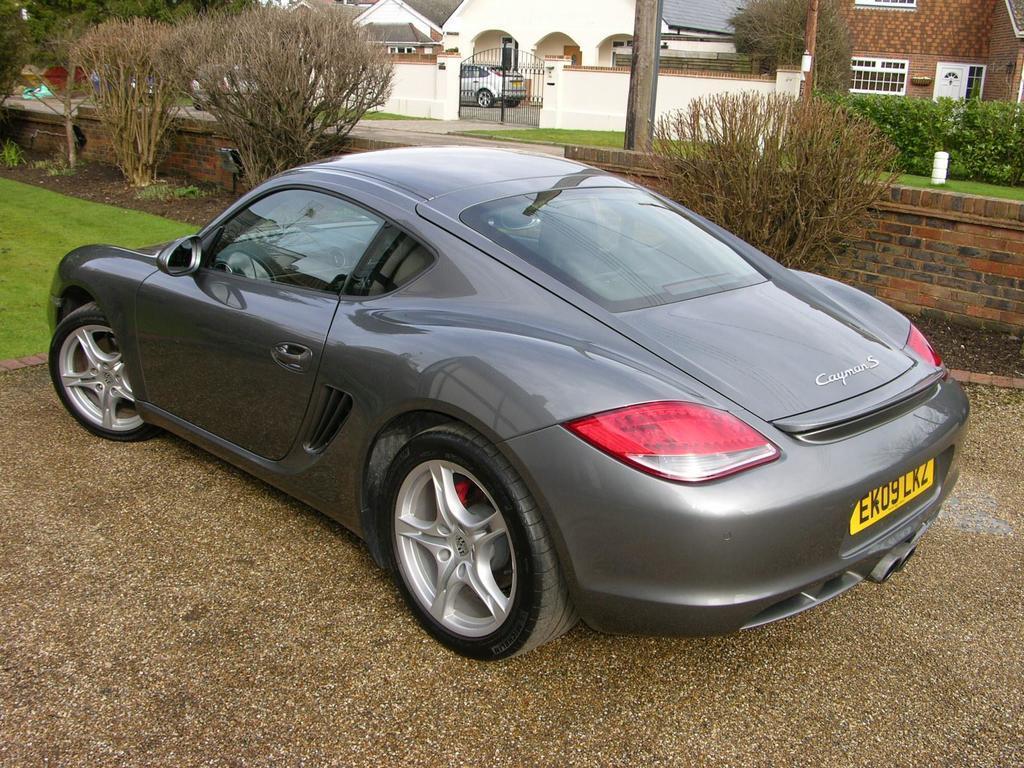How would you summarize this image in a sentence or two? In the middle of this image, there is a gray color vehicle on a road. Beside this road, there is grass on the ground and there are plants. Beside these plants, there is a brick wall. In the background, there are buildings, a pole, a wall, a vehicle, plants and a road. 